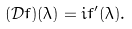<formula> <loc_0><loc_0><loc_500><loc_500>( { \mathcal { D } } f ) ( \lambda ) = i f ^ { \prime } ( \lambda ) .</formula> 